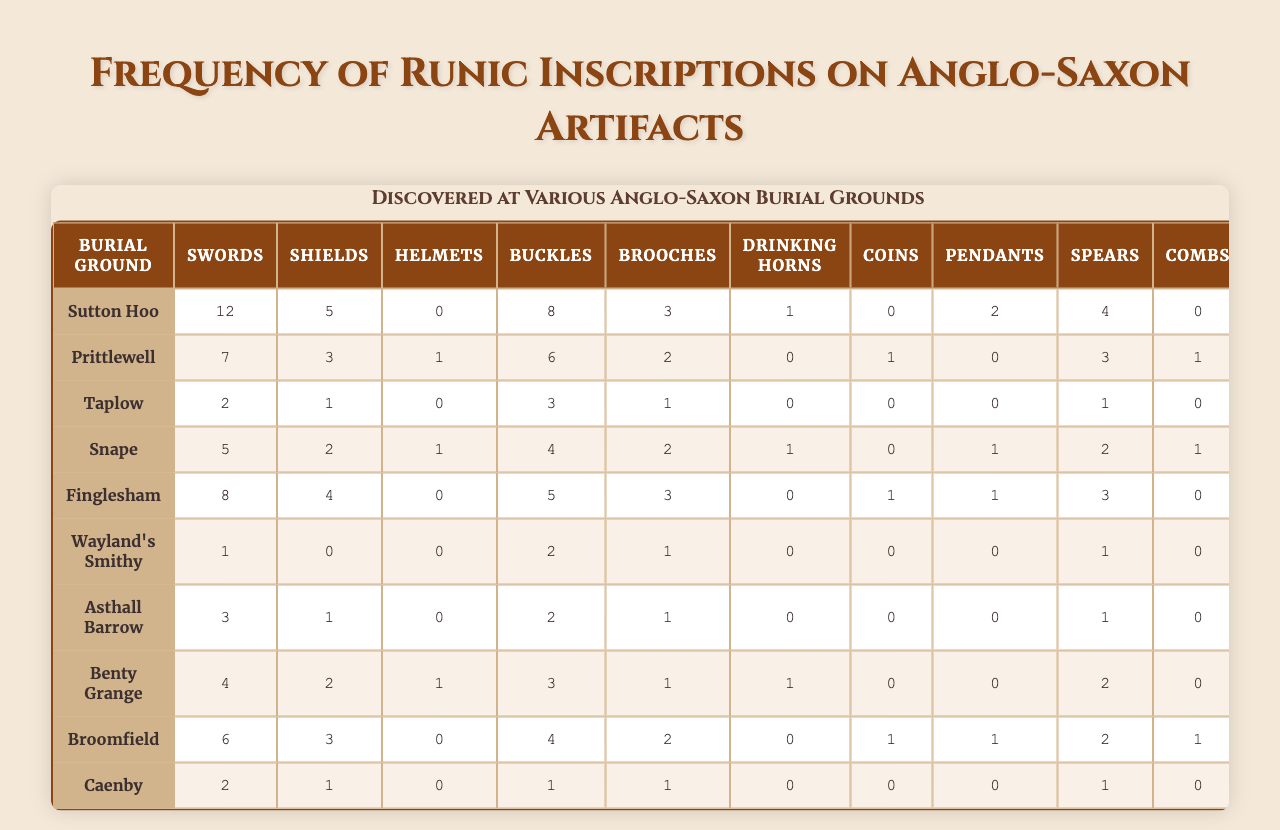What burial ground has the highest frequency of runic inscriptions on swords? Looking at the table, Sutton Hoo has 12 inscriptions for swords, which is the highest count compared to other burial grounds.
Answer: Sutton Hoo What is the total number of runic inscriptions found on helmets across all burial grounds? By adding the counts of runic inscriptions for helmets (0, 1, 0, 1, 0, 0, 0, 1, 0, 0), we get 0 + 1 + 0 + 1 + 0 + 0 + 0 + 1 + 0 + 0 = 3.
Answer: 3 Which artifact type has the lowest frequency of runic inscriptions at Snape? At Snape, the lowest frequency is for helmets, which has 1 inscription, while all others have higher counts.
Answer: Helmets What is the average number of runic inscriptions on coins from all burial grounds? Adding the counts for coins gives 0 + 1 + 0 + 1 + 0 + 0 + 0 + 0 + 1 + 0 = 3. There are 10 burial grounds, so the average is 3/10 = 0.3.
Answer: 0.3 Are there any burial grounds where no runic inscriptions were found on drinking horns? Checking each burial ground, we see that all counts for drinking horns are either 0 or more, specifically at Prittlewell, Taplow, Wayland's Smithy, Asthall Barrow, Benty Grange, Broomfield, and Caenby, indicating no runic inscriptions were found for several burial grounds.
Answer: Yes Which burial ground has a total of 18 runic inscriptions across all artifact types? Summing the counts for each burial ground: Sutton Hoo (12 + 5 + 0 + 8 + 3 + 1 + 0 + 2 + 4 + 0 = 35), Prittlewell (7 + 3 + 1 + 6 + 2 + 0 + 1 + 0 + 3 + 1 = 24), Taplow (2 + 1 + 0 + 3 + 1 + 0 + 0 + 0 + 1 + 0 = 8), Snape (5 + 2 + 1 + 4 + 2 + 1 + 0 + 1 + 2 + 1 = 19), Finglesham (8 + 4 + 0 + 5 + 3 + 0 + 1 + 1 + 3 + 0 = 25), Wayland's Smithy (1 + 0 + 0 + 2 + 1 + 0 + 0 + 0 + 1 + 0 = 5), Asthall Barrow (3 + 1 + 0 + 2 + 1 + 0 + 0 + 0 + 1 + 0 = 8), Benty Grange (4 + 2 + 1 + 3 + 1 + 1 + 0 + 0 + 2 + 0 = 14), Broomfield (6 + 3 + 0 + 4 + 2 + 0 + 1 + 1 + 2 + 1 = 20), Caenby (2 + 1 + 0 + 1 + 1 + 0 + 0 + 0 + 1 + 0 = 6). No burial ground has a total of 18 inscriptions.
Answer: No Which burial ground has the highest number of runic inscriptions for brooches? Evaluating the brooch counts, Sutton Hoo has 3, Prittlewell has 2, Taplow has 1, Snape has 2, Finglesham has 3, Wayland's Smithy has 0, Asthall Barrow has 0, Benty Grange has 1, Broomfield has 2, and Caenby has 0. Sutton Hoo and Finglesham are tied with 3 inscriptions for brooches but no other site has more.
Answer: Sutton Hoo and Finglesham What is the difference between the highest and lowest number of runic inscriptions for shields? For shields, Sutton Hoo has 5, and Wayland's Smithy has none, so the difference is 5 - 0 = 5.
Answer: 5 Is it true that more runic inscriptions are found on swords than on coins across all burial grounds? Adding up, swords have a total of 12 + 7 + 2 + 5 + 8 + 1 + 3 + 4 + 6 + 2 = 48 inscriptions, while coins have 3, which means the statement holds true.
Answer: Yes 